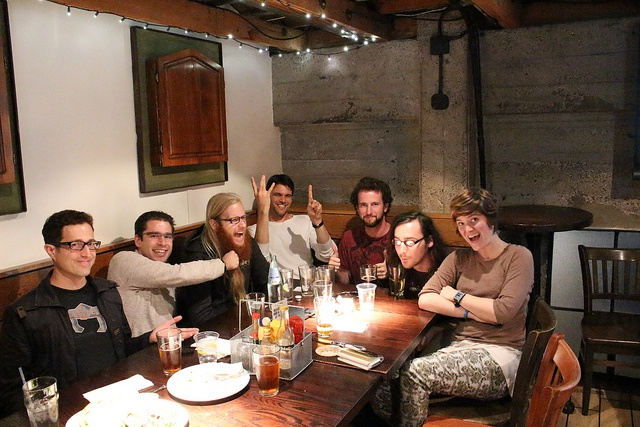Describe the objects in this image and their specific colors. I can see dining table in black, white, maroon, and brown tones, people in black, gray, and maroon tones, people in black and salmon tones, people in black, tan, and gray tones, and chair in black and gray tones in this image. 